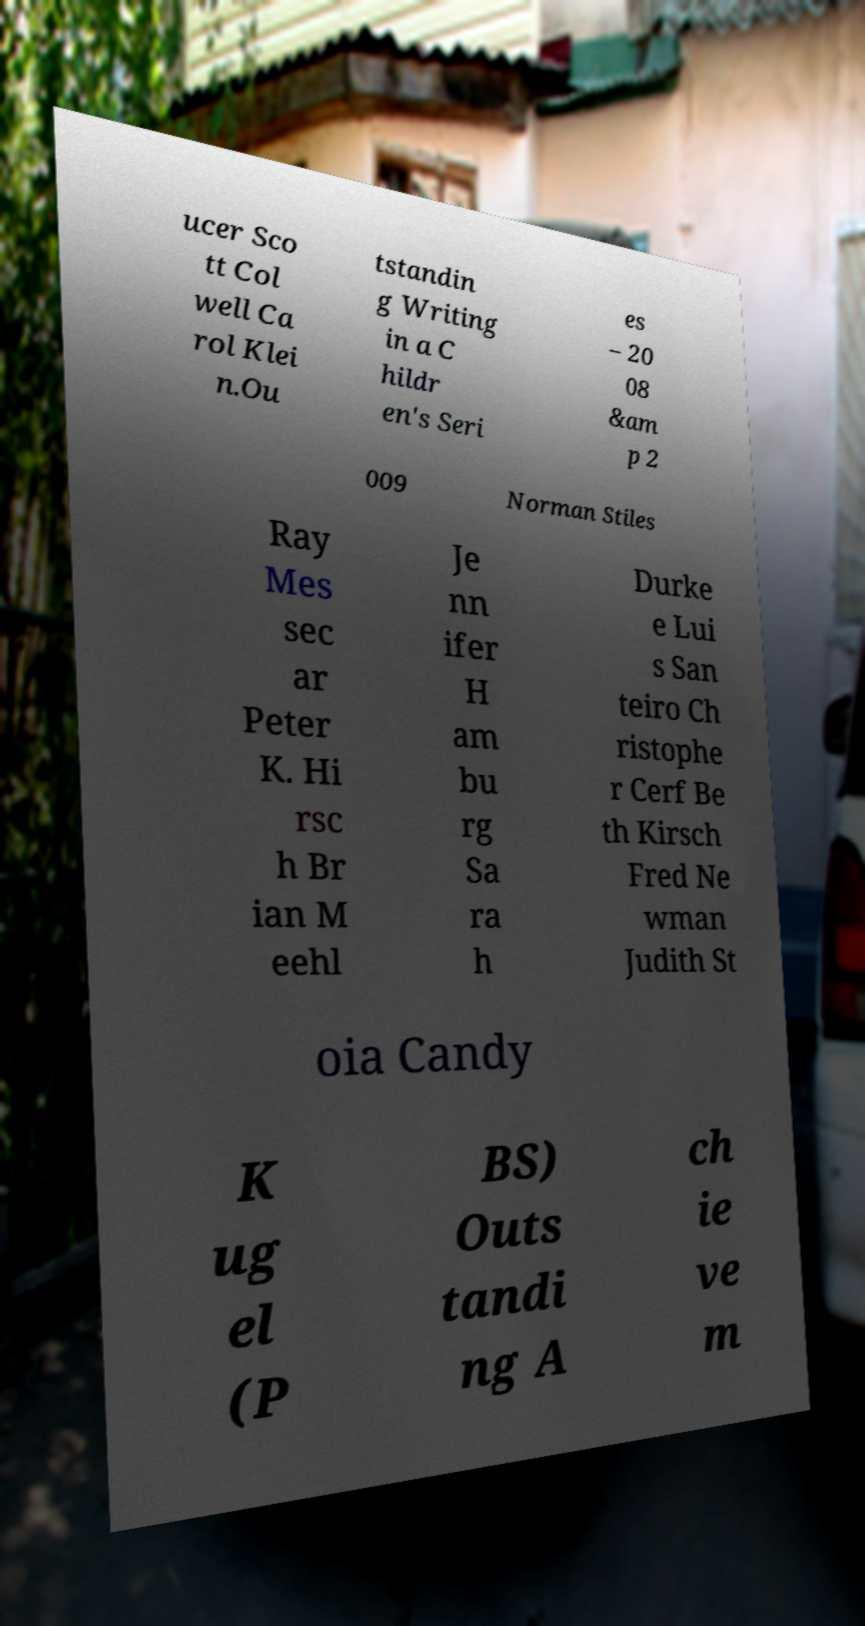Can you read and provide the text displayed in the image?This photo seems to have some interesting text. Can you extract and type it out for me? ucer Sco tt Col well Ca rol Klei n.Ou tstandin g Writing in a C hildr en's Seri es – 20 08 &am p 2 009 Norman Stiles Ray Mes sec ar Peter K. Hi rsc h Br ian M eehl Je nn ifer H am bu rg Sa ra h Durke e Lui s San teiro Ch ristophe r Cerf Be th Kirsch Fred Ne wman Judith St oia Candy K ug el (P BS) Outs tandi ng A ch ie ve m 